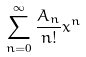<formula> <loc_0><loc_0><loc_500><loc_500>\sum _ { n = 0 } ^ { \infty } \frac { A _ { n } } { n ! } x ^ { n }</formula> 